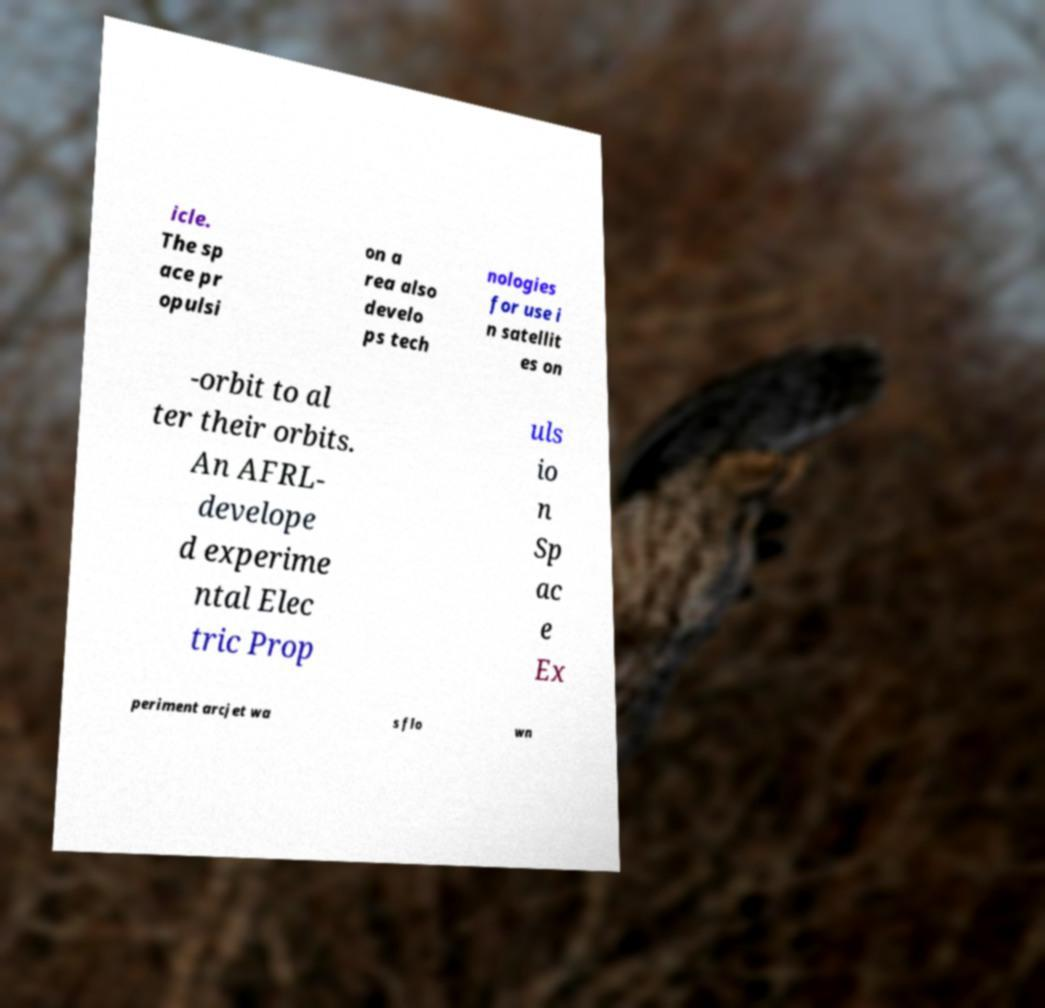Can you read and provide the text displayed in the image?This photo seems to have some interesting text. Can you extract and type it out for me? icle. The sp ace pr opulsi on a rea also develo ps tech nologies for use i n satellit es on -orbit to al ter their orbits. An AFRL- develope d experime ntal Elec tric Prop uls io n Sp ac e Ex periment arcjet wa s flo wn 